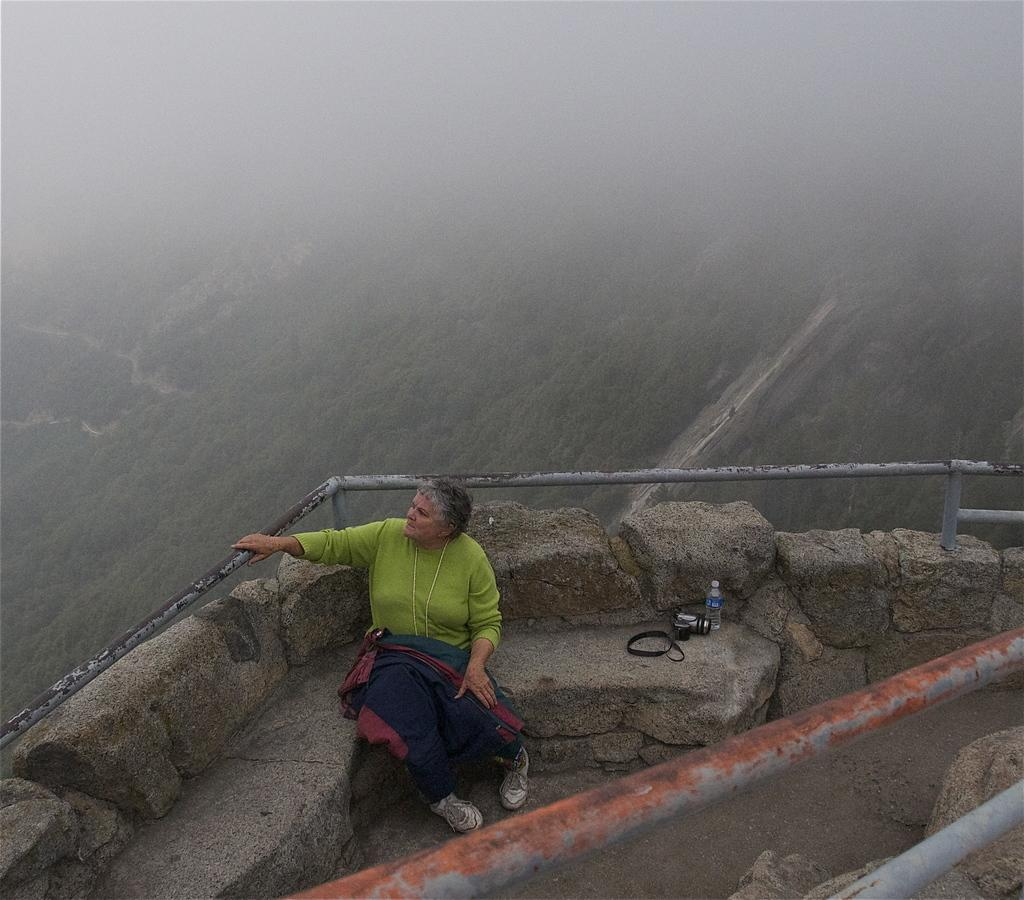What can be seen in the foreground of the picture? In the foreground of the picture, there are railings, a camera, a bottle, and a woman sitting. What is the woman doing in the picture? The woman is sitting in the foreground of the picture. What is visible in the background of the picture? There are trees in the background of the picture. How would you describe the top part of the image? The top part of the image is foggy. How many planes can be seen flying over the trees in the background of the image? There are no planes visible in the image; only trees can be seen in the background. Are there any fairies visible in the image? There are no fairies present in the image. 